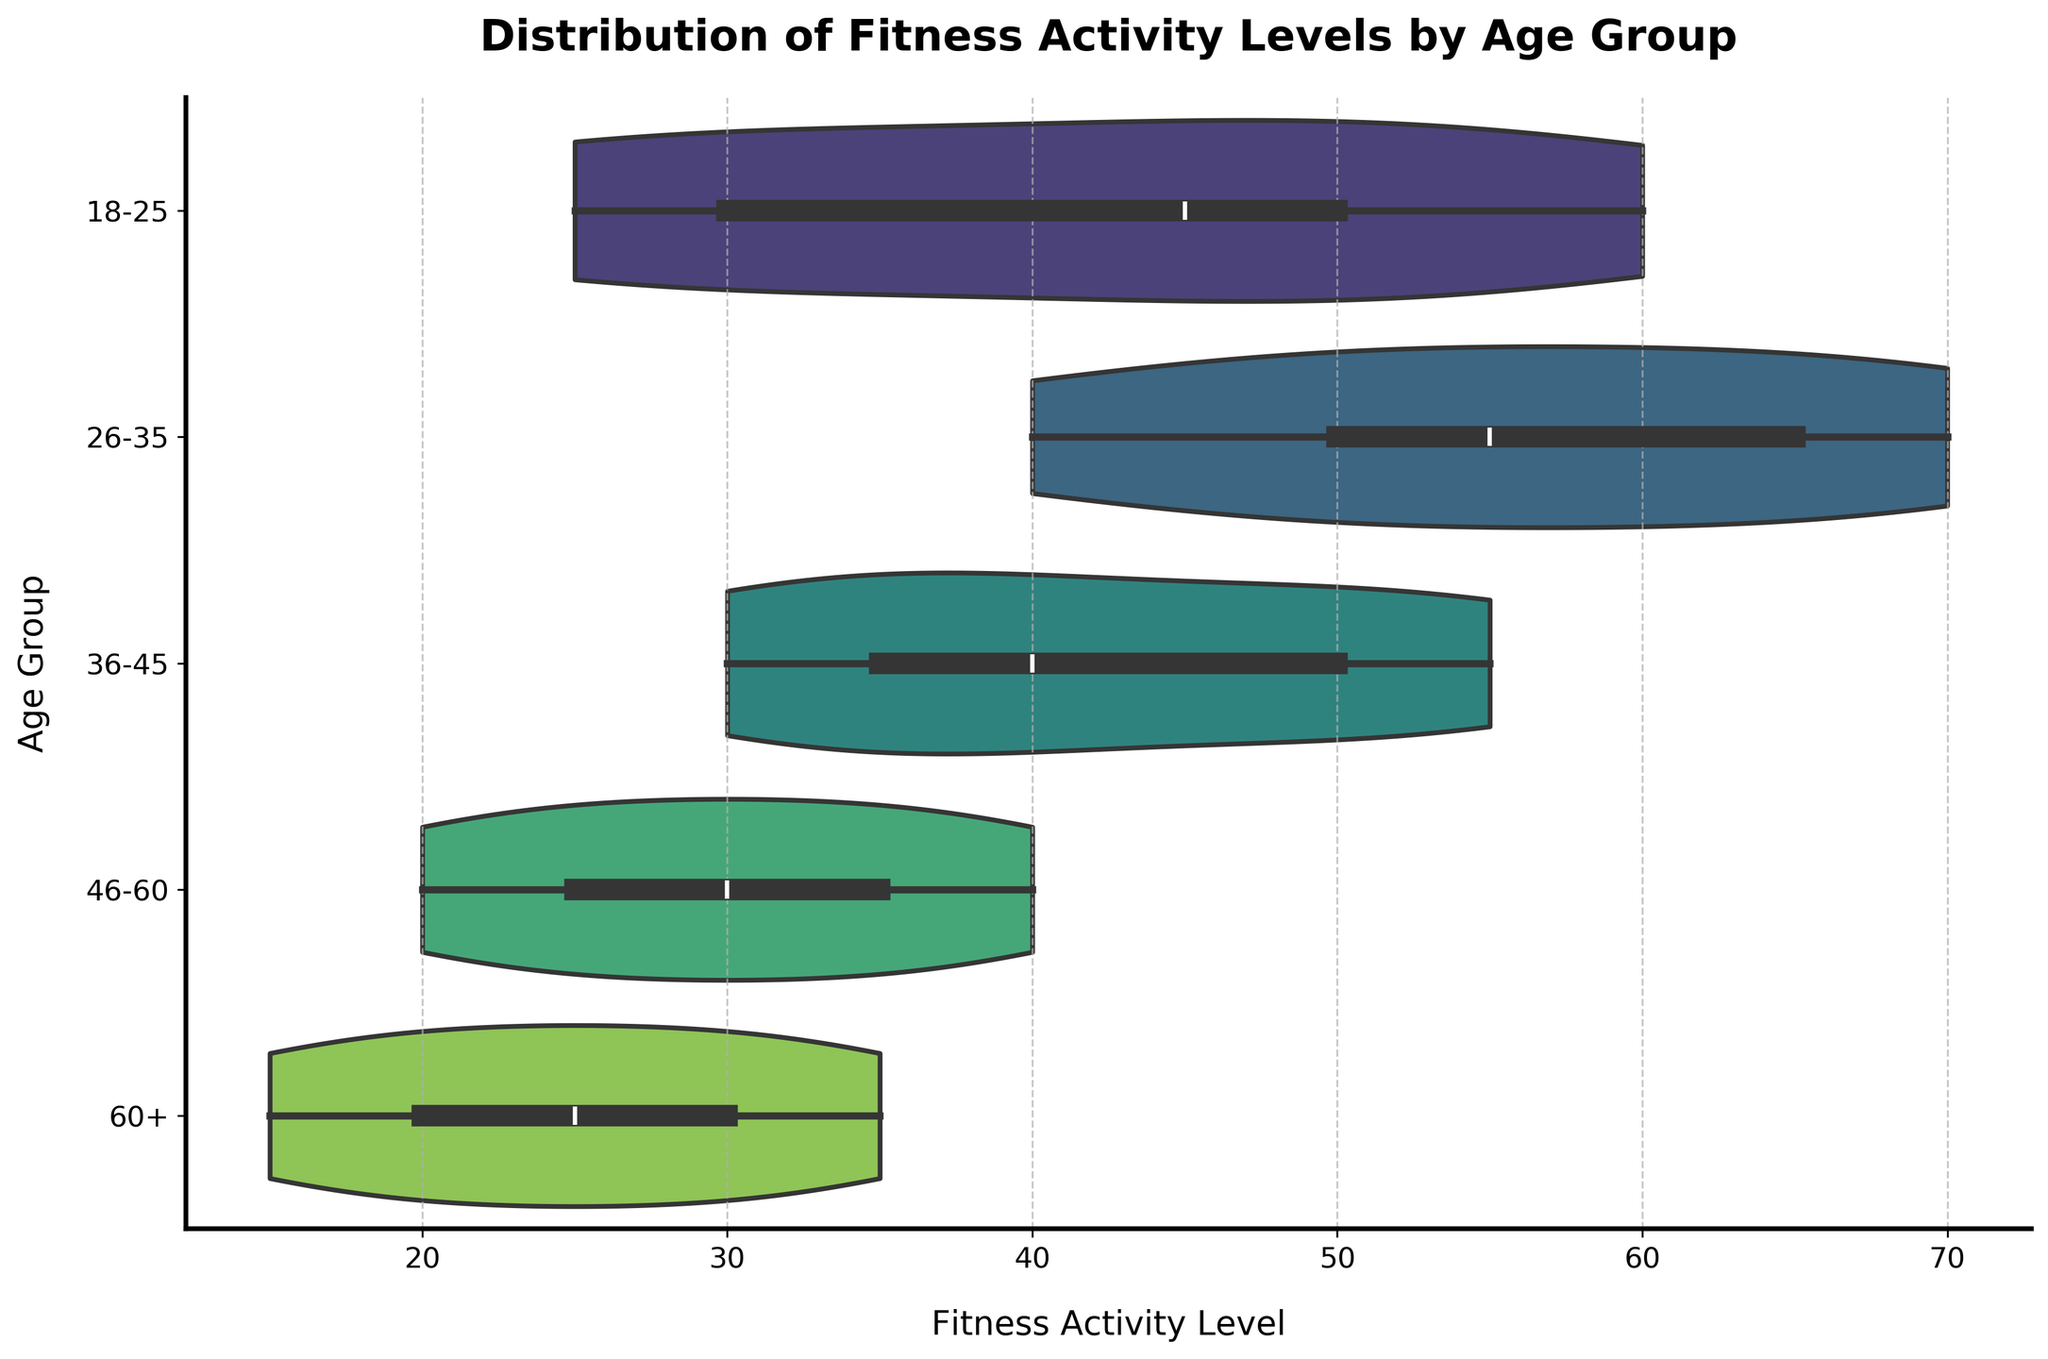What is the title of the chart? The title of the chart is displayed at the top-center of the figure, describing the overall purpose of the visualization. It reads 'Distribution of Fitness Activity Levels by Age Group'.
Answer: ‘Distribution of Fitness Activity Levels by Age Group’ What are the labels of the x-axis and y-axis? The labels of the axes provide context regarding what the axes represent. The x-axis is labeled 'Fitness Activity Level' and the y-axis is labeled 'Age Group'.
Answer: 'Fitness Activity Level' and 'Age Group' Which age group seems to have the highest median fitness activity level? The median is typically represented by the white dot within the violin plot. By visually identifying the central position of the white dots across all age groups, it can be observed that the age group 26-35 has the highest median.
Answer: 26-35 What is the approximate range of fitness activity levels for the age group 18-25? By observing the extent of the violin plot which represents the spread of the data for age group 18-25, it spans from approximately 25 to 60.
Answer: 25 to 60 Which age group has the smallest spread in fitness activity levels? The spread refers to the width of the violin plot. By comparing the widths of the violin plots, the group 60+ has the smallest spread, as it is the narrowest.
Answer: 60+ How do the averages of the 26-35 and 46-60 age groups compare? Visually, calculate the rough central tendency by averaging the data points within the violin plots for each age group. The 26-35 age group has a wider and higher distribution, indicating a higher average compared to the 46-60 age group.
Answer: 26-35 has a higher average Which age group shows the widest distribution of fitness activity levels? The widest distribution is indicated by the length of the violin plot. The 26-35 age group has the widest distribution because its plot spans from about 40 to 70.
Answer: 26-35 Do any age groups overlap in their ranges of fitness activity? If so, which ones? By comparing the start and end points of the distributions on the x-axis, it can be seen that multiple age groups (e.g., 18-25 and 36-45) have overlapping fitness activity levels.
Answer: Yes, 18-25 and 36-45 